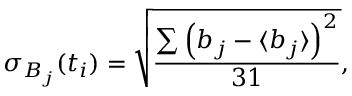<formula> <loc_0><loc_0><loc_500><loc_500>\sigma _ { B _ { j } } ( t _ { i } ) = \sqrt { \frac { \sum \left ( b _ { j } - \langle { b _ { j } } \rangle \right ) ^ { 2 } } { 3 1 } } ,</formula> 